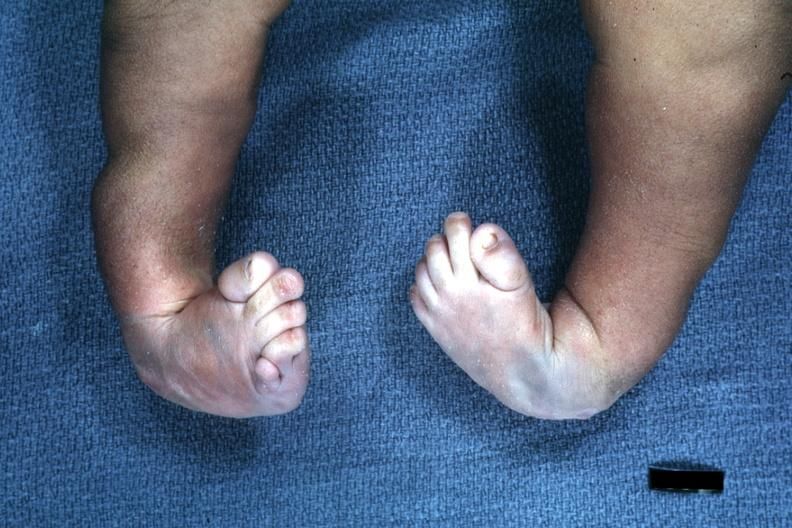what are present?
Answer the question using a single word or phrase. Extremities 